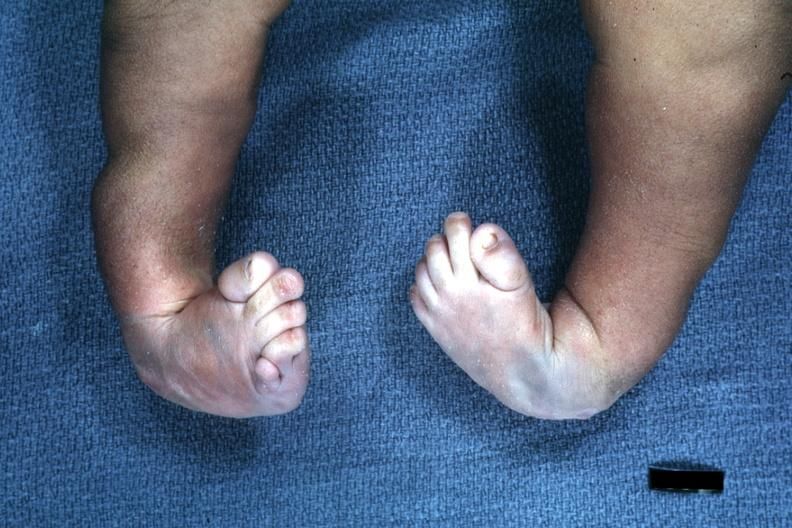what are present?
Answer the question using a single word or phrase. Extremities 